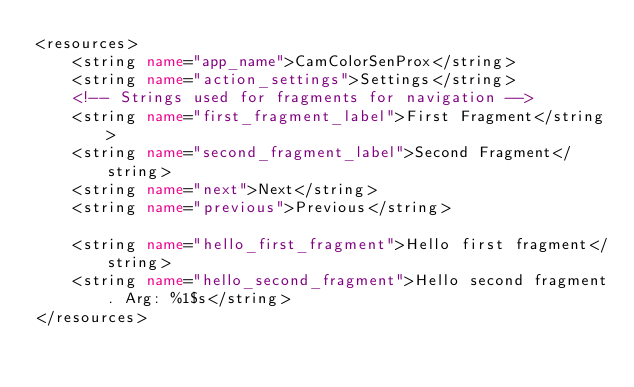<code> <loc_0><loc_0><loc_500><loc_500><_XML_><resources>
    <string name="app_name">CamColorSenProx</string>
    <string name="action_settings">Settings</string>
    <!-- Strings used for fragments for navigation -->
    <string name="first_fragment_label">First Fragment</string>
    <string name="second_fragment_label">Second Fragment</string>
    <string name="next">Next</string>
    <string name="previous">Previous</string>

    <string name="hello_first_fragment">Hello first fragment</string>
    <string name="hello_second_fragment">Hello second fragment. Arg: %1$s</string>
</resources></code> 